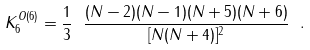Convert formula to latex. <formula><loc_0><loc_0><loc_500><loc_500>K _ { 6 } ^ { O ( 6 ) } = \frac { 1 } { 3 } \ \frac { ( N - 2 ) ( N - 1 ) ( N + 5 ) ( N + 6 ) } { [ N ( N + 4 ) ] ^ { 2 } } \ .</formula> 